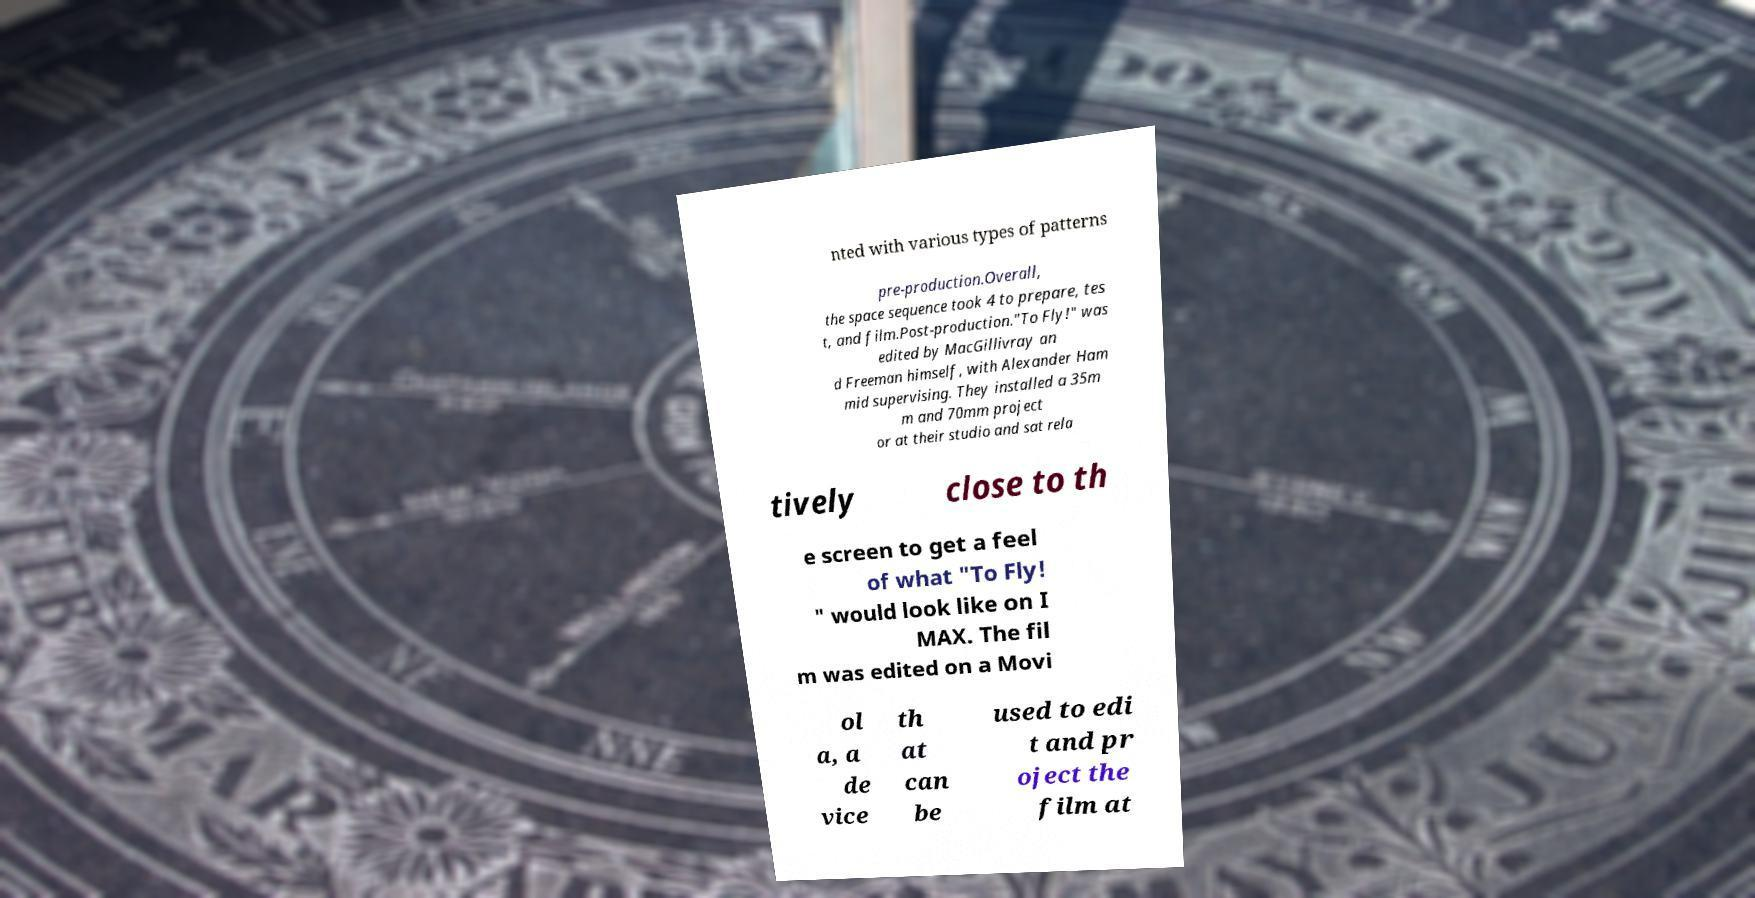Could you assist in decoding the text presented in this image and type it out clearly? nted with various types of patterns pre-production.Overall, the space sequence took 4 to prepare, tes t, and film.Post-production."To Fly!" was edited by MacGillivray an d Freeman himself, with Alexander Ham mid supervising. They installed a 35m m and 70mm project or at their studio and sat rela tively close to th e screen to get a feel of what "To Fly! " would look like on I MAX. The fil m was edited on a Movi ol a, a de vice th at can be used to edi t and pr oject the film at 